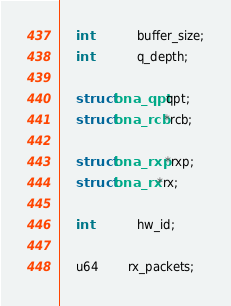<code> <loc_0><loc_0><loc_500><loc_500><_C_>	int			buffer_size;
	int			q_depth;

	struct bna_qpt qpt;
	struct bna_rcb *rcb;

	struct bna_rxp *rxp;
	struct bna_rx *rx;

	int			hw_id;

	u64		rx_packets;</code> 